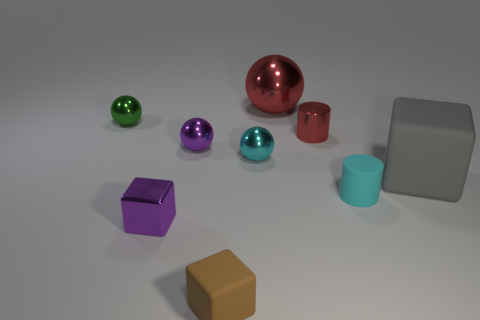Are there any rubber cubes in front of the tiny cyan rubber cylinder?
Your answer should be very brief. Yes. What number of other objects are the same size as the green object?
Ensure brevity in your answer.  6. What is the material of the tiny object that is both in front of the tiny red cylinder and right of the cyan metal sphere?
Offer a terse response. Rubber. Does the purple object behind the big rubber thing have the same shape as the small thing that is on the left side of the tiny metallic cube?
Keep it short and to the point. Yes. Is there anything else that is the same material as the brown block?
Keep it short and to the point. Yes. There is a red metallic thing right of the big thing that is behind the small purple shiny thing that is behind the gray object; what shape is it?
Offer a terse response. Cylinder. What number of other things are the same shape as the big metallic object?
Your answer should be very brief. 3. What is the color of the matte cylinder that is the same size as the green metal thing?
Ensure brevity in your answer.  Cyan. How many blocks are tiny purple things or big gray matte objects?
Make the answer very short. 2. What number of cubes are there?
Offer a very short reply. 3. 